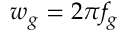Convert formula to latex. <formula><loc_0><loc_0><loc_500><loc_500>w _ { g } = 2 \pi f _ { g }</formula> 